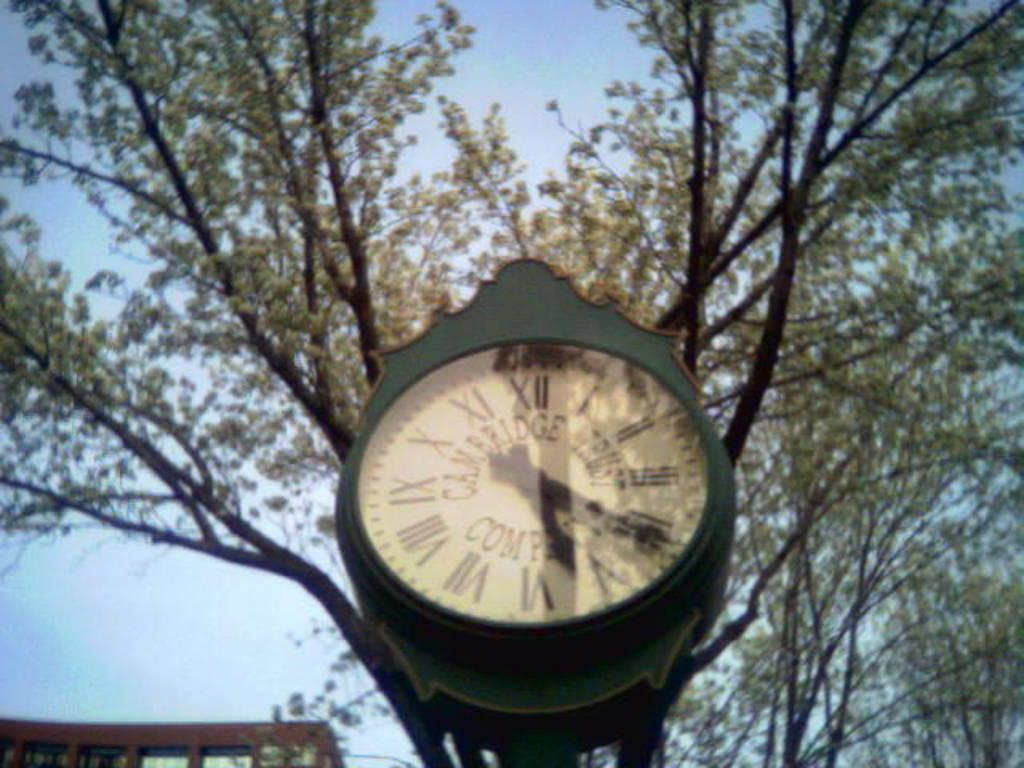<image>
Describe the image concisely. A cambridge trust company clock outside in front of a tree. 